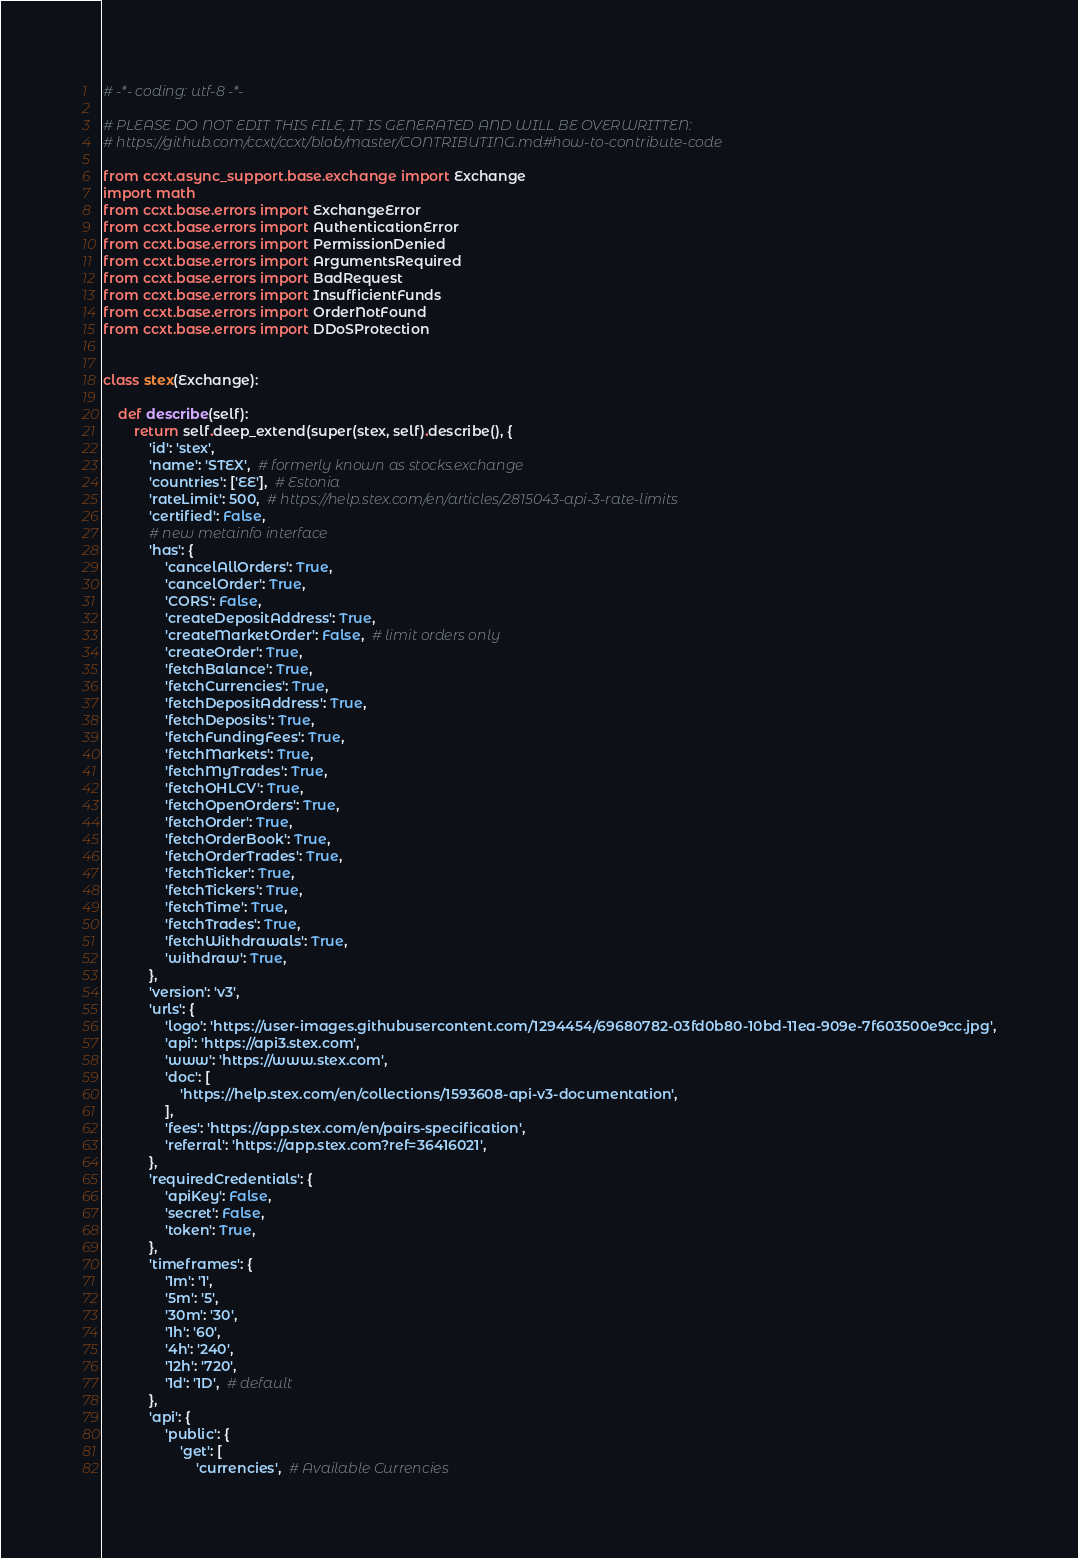Convert code to text. <code><loc_0><loc_0><loc_500><loc_500><_Python_># -*- coding: utf-8 -*-

# PLEASE DO NOT EDIT THIS FILE, IT IS GENERATED AND WILL BE OVERWRITTEN:
# https://github.com/ccxt/ccxt/blob/master/CONTRIBUTING.md#how-to-contribute-code

from ccxt.async_support.base.exchange import Exchange
import math
from ccxt.base.errors import ExchangeError
from ccxt.base.errors import AuthenticationError
from ccxt.base.errors import PermissionDenied
from ccxt.base.errors import ArgumentsRequired
from ccxt.base.errors import BadRequest
from ccxt.base.errors import InsufficientFunds
from ccxt.base.errors import OrderNotFound
from ccxt.base.errors import DDoSProtection


class stex(Exchange):

    def describe(self):
        return self.deep_extend(super(stex, self).describe(), {
            'id': 'stex',
            'name': 'STEX',  # formerly known as stocks.exchange
            'countries': ['EE'],  # Estonia
            'rateLimit': 500,  # https://help.stex.com/en/articles/2815043-api-3-rate-limits
            'certified': False,
            # new metainfo interface
            'has': {
                'cancelAllOrders': True,
                'cancelOrder': True,
                'CORS': False,
                'createDepositAddress': True,
                'createMarketOrder': False,  # limit orders only
                'createOrder': True,
                'fetchBalance': True,
                'fetchCurrencies': True,
                'fetchDepositAddress': True,
                'fetchDeposits': True,
                'fetchFundingFees': True,
                'fetchMarkets': True,
                'fetchMyTrades': True,
                'fetchOHLCV': True,
                'fetchOpenOrders': True,
                'fetchOrder': True,
                'fetchOrderBook': True,
                'fetchOrderTrades': True,
                'fetchTicker': True,
                'fetchTickers': True,
                'fetchTime': True,
                'fetchTrades': True,
                'fetchWithdrawals': True,
                'withdraw': True,
            },
            'version': 'v3',
            'urls': {
                'logo': 'https://user-images.githubusercontent.com/1294454/69680782-03fd0b80-10bd-11ea-909e-7f603500e9cc.jpg',
                'api': 'https://api3.stex.com',
                'www': 'https://www.stex.com',
                'doc': [
                    'https://help.stex.com/en/collections/1593608-api-v3-documentation',
                ],
                'fees': 'https://app.stex.com/en/pairs-specification',
                'referral': 'https://app.stex.com?ref=36416021',
            },
            'requiredCredentials': {
                'apiKey': False,
                'secret': False,
                'token': True,
            },
            'timeframes': {
                '1m': '1',
                '5m': '5',
                '30m': '30',
                '1h': '60',
                '4h': '240',
                '12h': '720',
                '1d': '1D',  # default
            },
            'api': {
                'public': {
                    'get': [
                        'currencies',  # Available Currencies</code> 